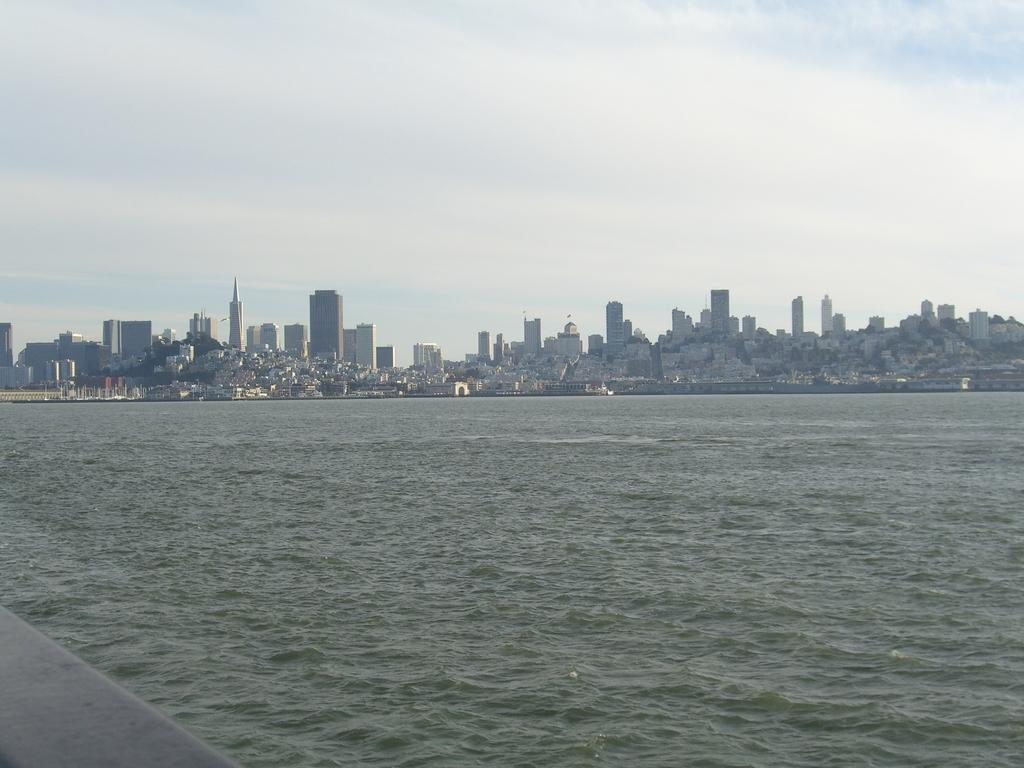What type of structures are present in the image? There is a group of buildings in the image. What else can be seen in the image besides the buildings? There are poles and a large water body visible in the image. What is visible in the background of the image? The sky is visible in the image. How would you describe the weather based on the appearance of the sky? The sky appears cloudy in the image. What type of yarn is being used to create the development in the image? There is no yarn or development present in the image; it features a group of buildings, poles, a large water body, and a cloudy sky. 